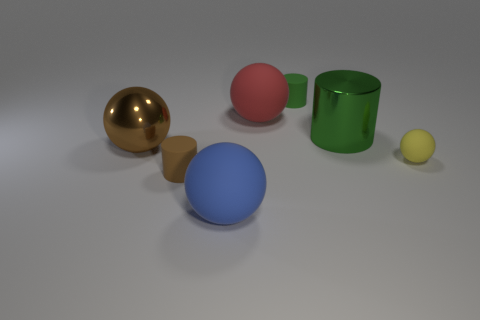Which object stands out the most in this set and why? The golden sphere stands out due to its reflective surface, which contrasts with the matte finish of the other objects. It catches the light and even reflects the environment, drawing the viewer's attention. Could you tell me what the environment being reflected suggests about where these objects might be? The reflected environment is minimal, with hints of other objects and a soft gradient. This suggests the objects are placed in a controlled setting, like a studio, for the purpose of focusing on their shapes and materials without background distraction. 